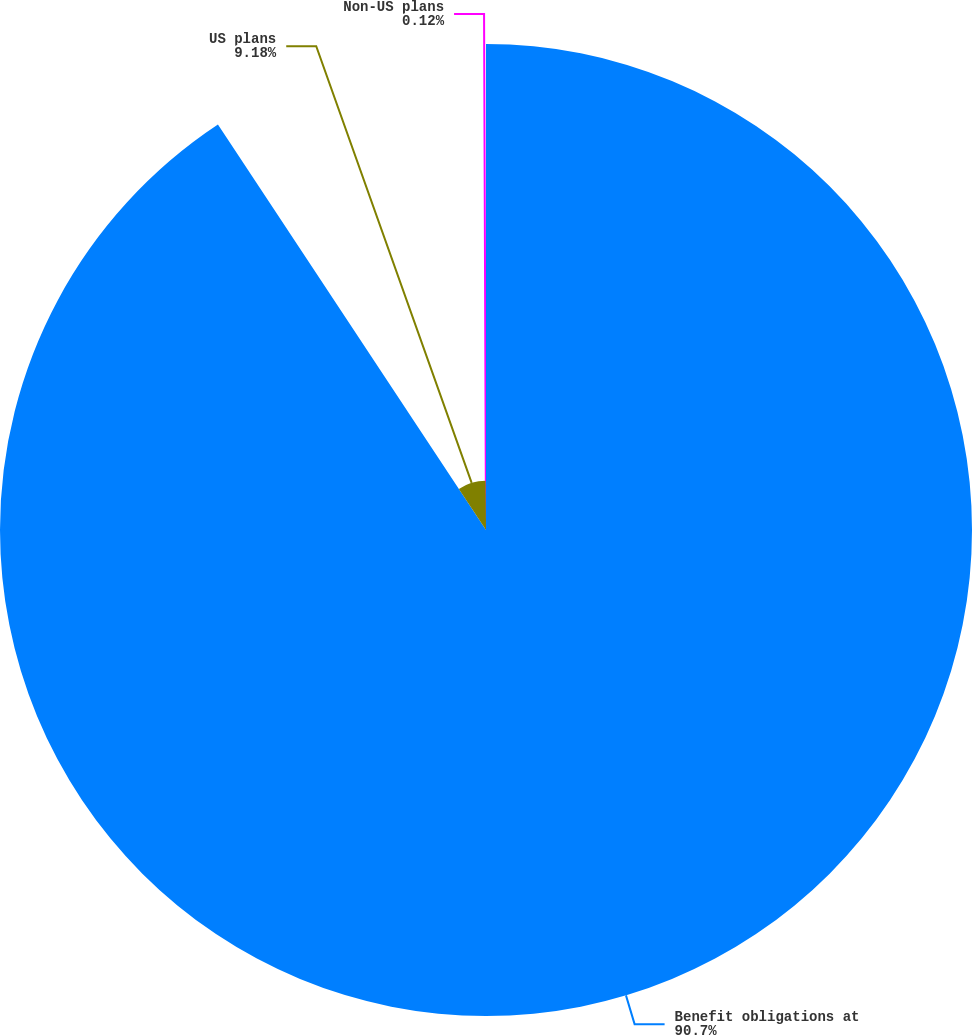<chart> <loc_0><loc_0><loc_500><loc_500><pie_chart><fcel>Benefit obligations at<fcel>US plans<fcel>Non-US plans<nl><fcel>90.71%<fcel>9.18%<fcel>0.12%<nl></chart> 